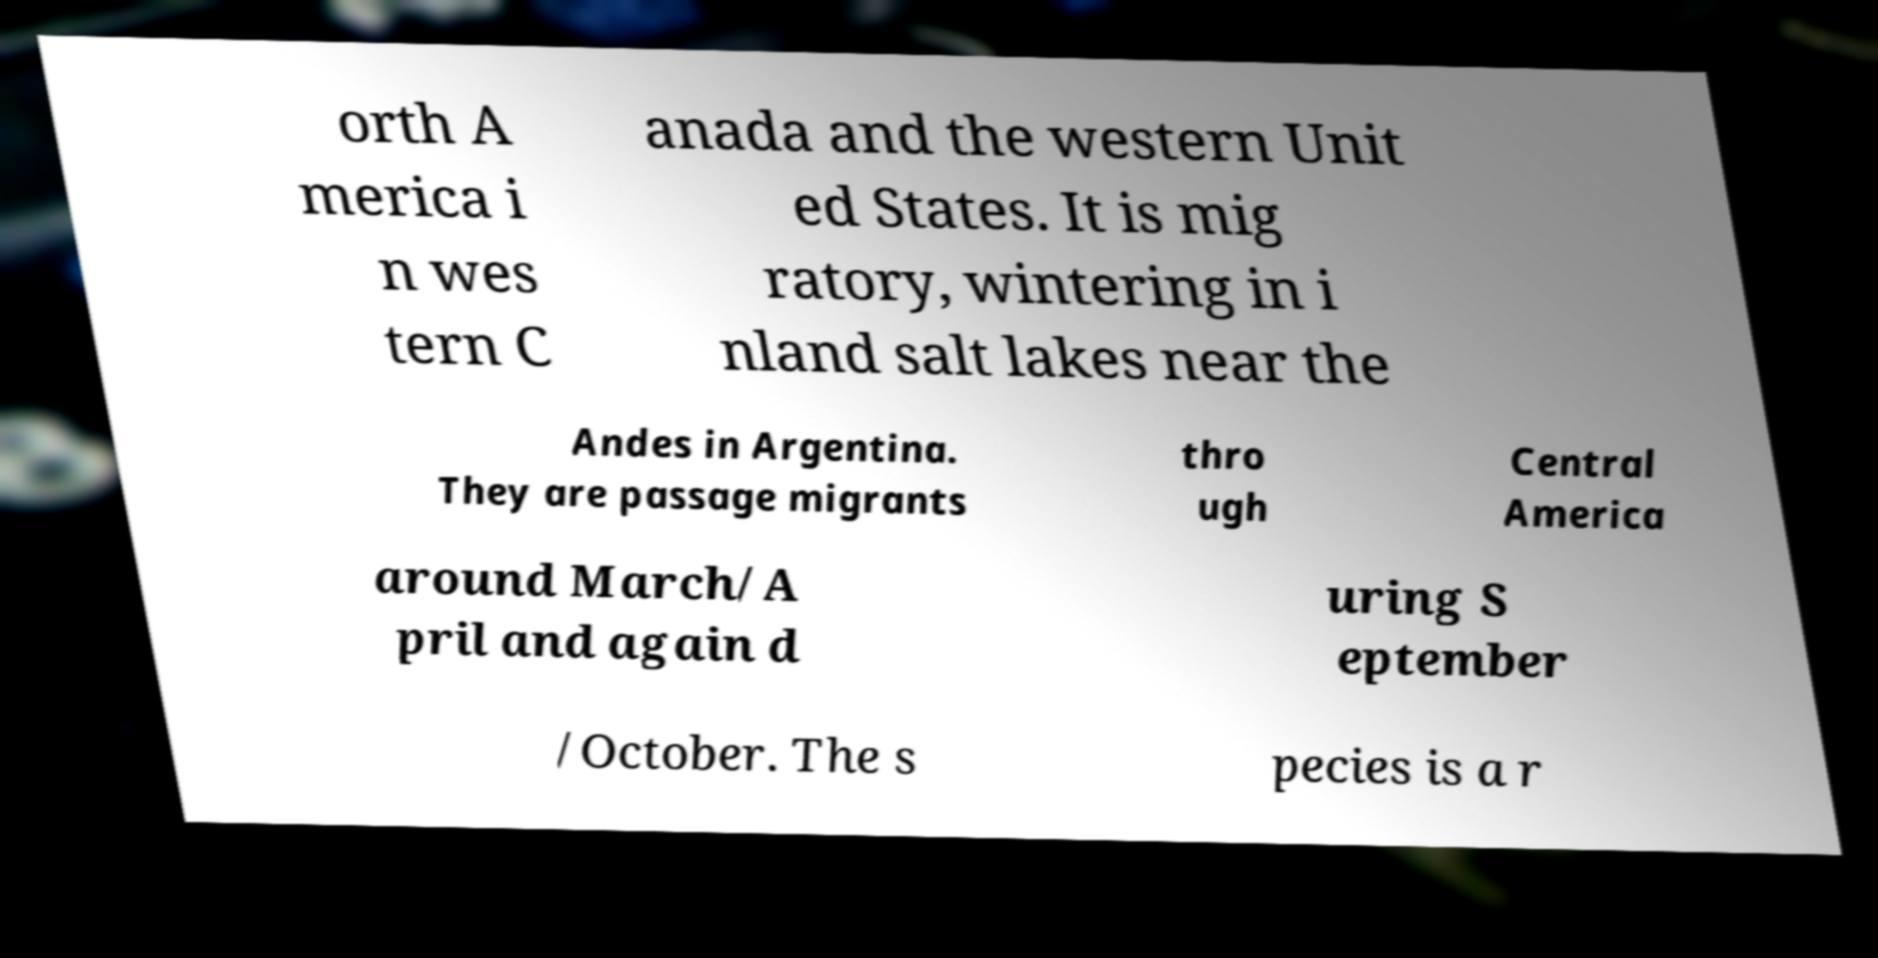Please read and relay the text visible in this image. What does it say? orth A merica i n wes tern C anada and the western Unit ed States. It is mig ratory, wintering in i nland salt lakes near the Andes in Argentina. They are passage migrants thro ugh Central America around March/A pril and again d uring S eptember /October. The s pecies is a r 